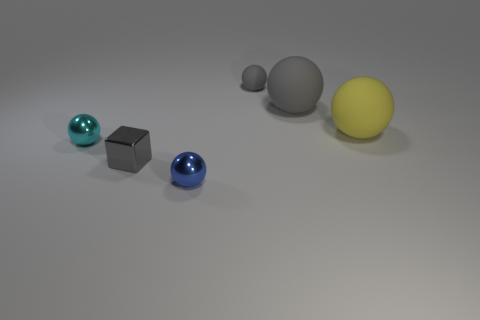Are there any spheres to the right of the large thing that is on the right side of the large gray rubber ball?
Your answer should be very brief. No. Are there any tiny objects right of the gray cube?
Your answer should be very brief. Yes. Is the shape of the small gray thing behind the small cyan thing the same as  the tiny blue object?
Ensure brevity in your answer.  Yes. How many small gray metallic things have the same shape as the large yellow matte thing?
Offer a terse response. 0. Is there a tiny gray thing made of the same material as the tiny blue object?
Your response must be concise. Yes. There is a big thing that is on the left side of the large rubber thing in front of the large gray matte thing; what is its material?
Keep it short and to the point. Rubber. How big is the blue object right of the small cyan object?
Offer a very short reply. Small. Does the tiny cube have the same color as the ball that is to the left of the blue ball?
Make the answer very short. No. Are there any objects of the same color as the metal block?
Your answer should be very brief. Yes. Is the big gray ball made of the same material as the tiny ball behind the yellow sphere?
Make the answer very short. Yes. 